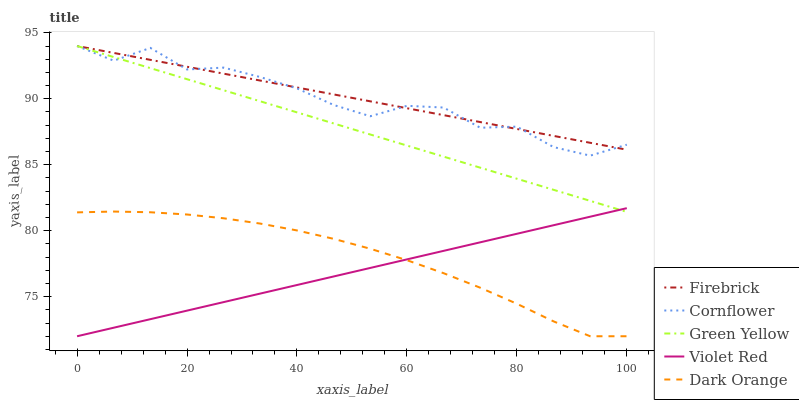Does Violet Red have the minimum area under the curve?
Answer yes or no. Yes. Does Firebrick have the maximum area under the curve?
Answer yes or no. Yes. Does Green Yellow have the minimum area under the curve?
Answer yes or no. No. Does Green Yellow have the maximum area under the curve?
Answer yes or no. No. Is Firebrick the smoothest?
Answer yes or no. Yes. Is Cornflower the roughest?
Answer yes or no. Yes. Is Green Yellow the smoothest?
Answer yes or no. No. Is Green Yellow the roughest?
Answer yes or no. No. Does Green Yellow have the lowest value?
Answer yes or no. No. Does Green Yellow have the highest value?
Answer yes or no. Yes. Does Violet Red have the highest value?
Answer yes or no. No. Is Violet Red less than Firebrick?
Answer yes or no. Yes. Is Cornflower greater than Dark Orange?
Answer yes or no. Yes. Does Green Yellow intersect Violet Red?
Answer yes or no. Yes. Is Green Yellow less than Violet Red?
Answer yes or no. No. Is Green Yellow greater than Violet Red?
Answer yes or no. No. Does Violet Red intersect Firebrick?
Answer yes or no. No. 